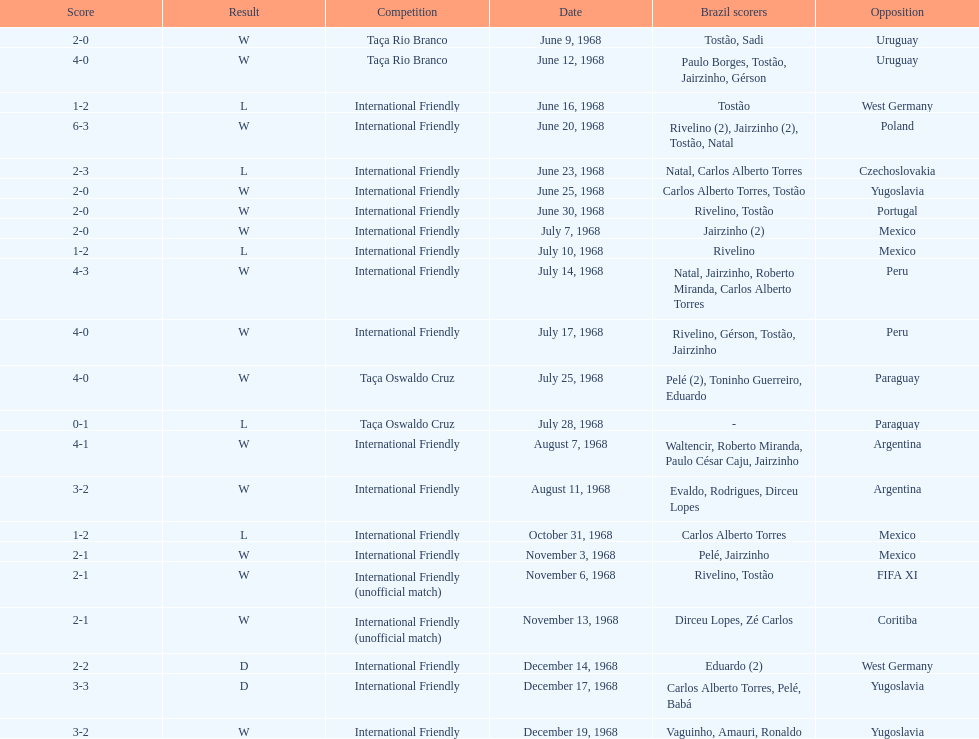The most goals scored by brazil in a game 6. 